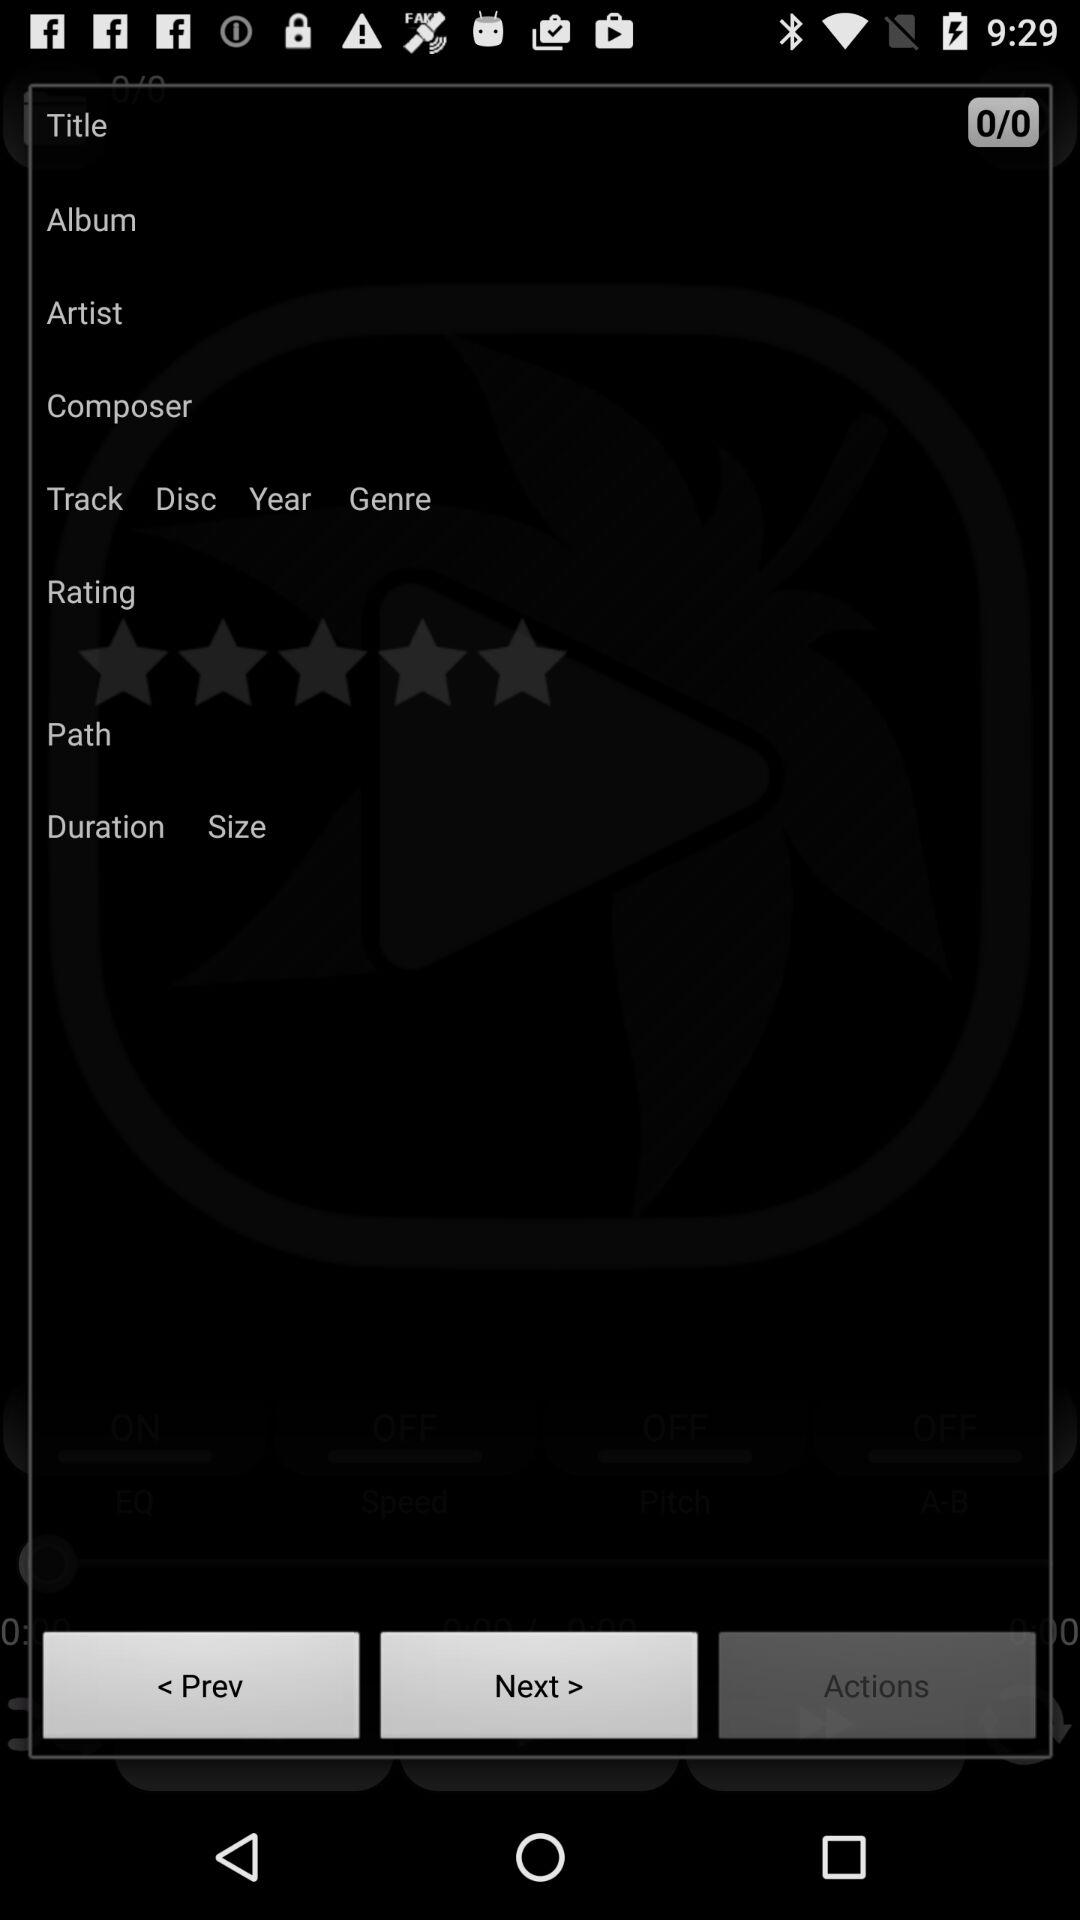Which button is highlighted? The button "Actions" is highlighted. 